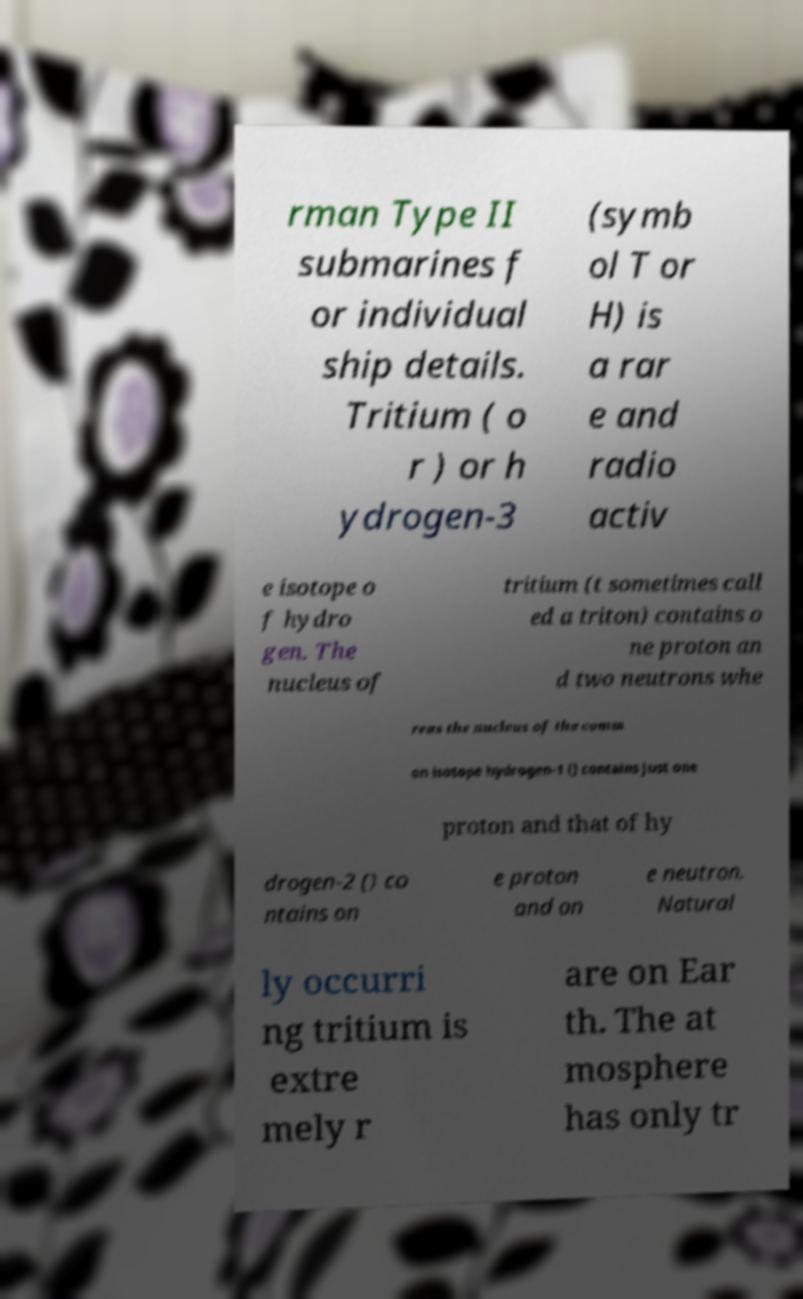What messages or text are displayed in this image? I need them in a readable, typed format. rman Type II submarines f or individual ship details. Tritium ( o r ) or h ydrogen-3 (symb ol T or H) is a rar e and radio activ e isotope o f hydro gen. The nucleus of tritium (t sometimes call ed a triton) contains o ne proton an d two neutrons whe reas the nucleus of the comm on isotope hydrogen-1 () contains just one proton and that of hy drogen-2 () co ntains on e proton and on e neutron. Natural ly occurri ng tritium is extre mely r are on Ear th. The at mosphere has only tr 